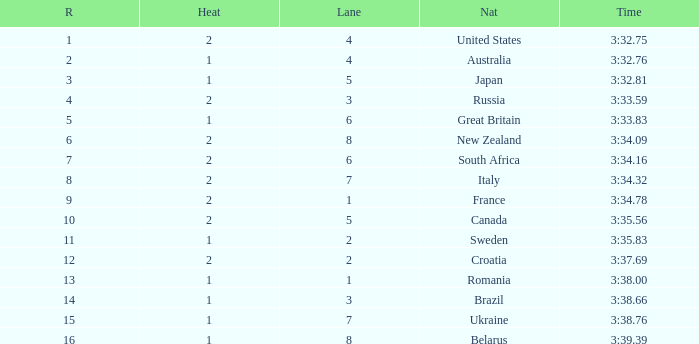Can you tell me the Rank that has the Lane of 6, and the Heat of 2? 7.0. 